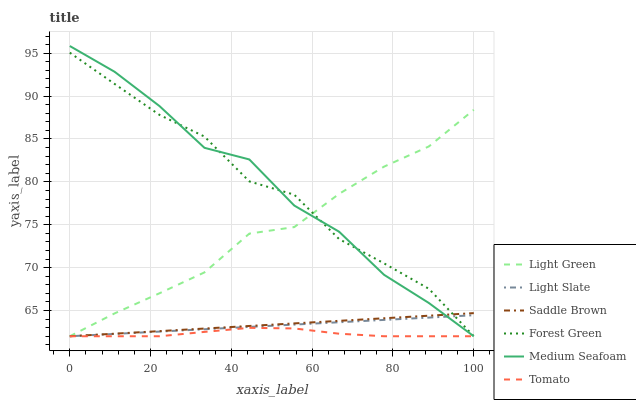Does Tomato have the minimum area under the curve?
Answer yes or no. Yes. Does Medium Seafoam have the maximum area under the curve?
Answer yes or no. Yes. Does Light Slate have the minimum area under the curve?
Answer yes or no. No. Does Light Slate have the maximum area under the curve?
Answer yes or no. No. Is Saddle Brown the smoothest?
Answer yes or no. Yes. Is Forest Green the roughest?
Answer yes or no. Yes. Is Light Slate the smoothest?
Answer yes or no. No. Is Light Slate the roughest?
Answer yes or no. No. Does Light Slate have the highest value?
Answer yes or no. No. 